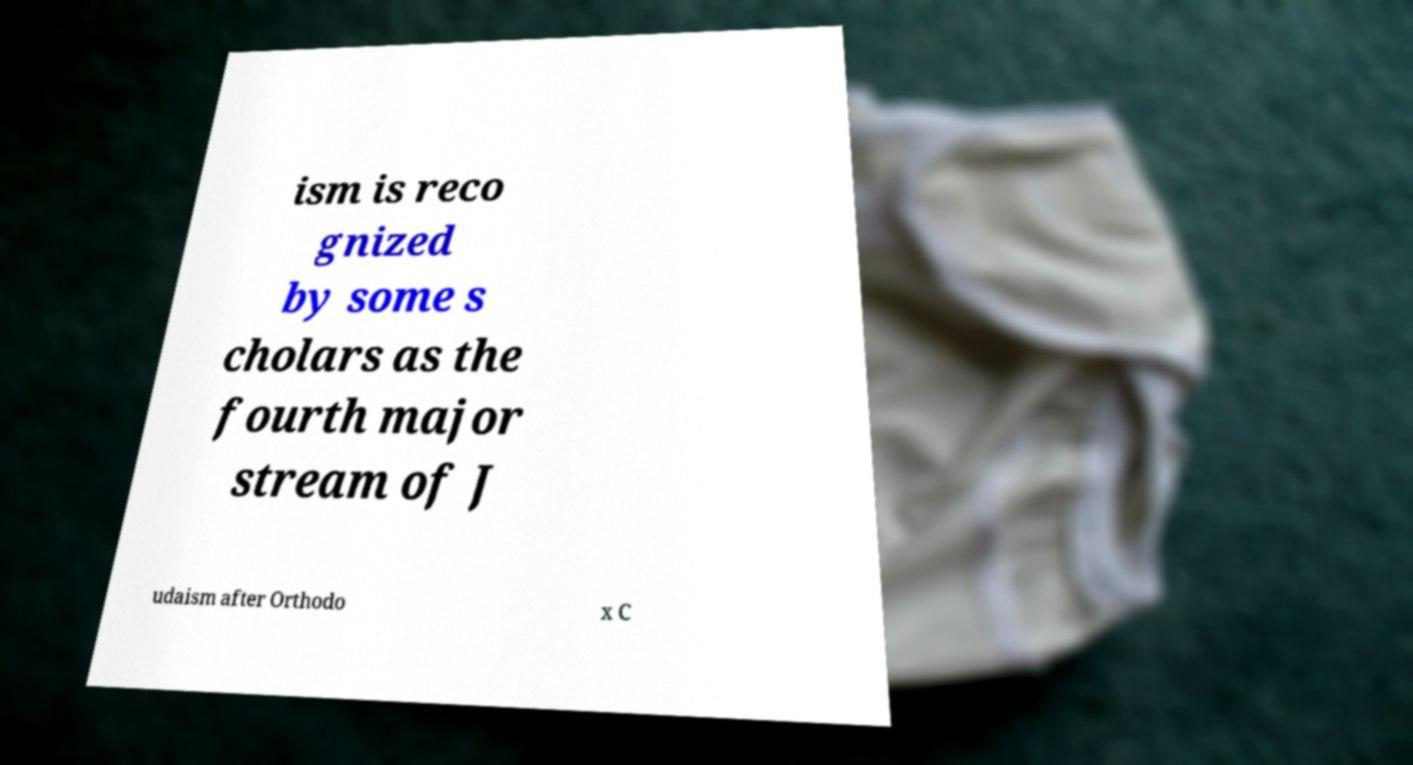Could you assist in decoding the text presented in this image and type it out clearly? ism is reco gnized by some s cholars as the fourth major stream of J udaism after Orthodo x C 